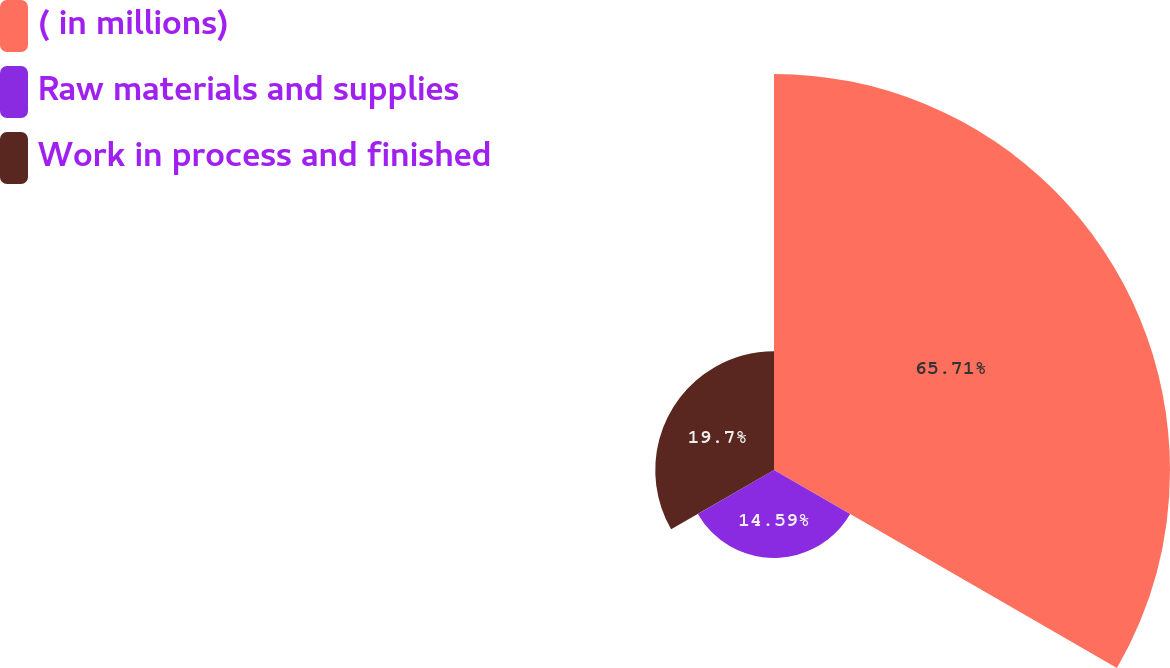Convert chart to OTSL. <chart><loc_0><loc_0><loc_500><loc_500><pie_chart><fcel>( in millions)<fcel>Raw materials and supplies<fcel>Work in process and finished<nl><fcel>65.7%<fcel>14.59%<fcel>19.7%<nl></chart> 